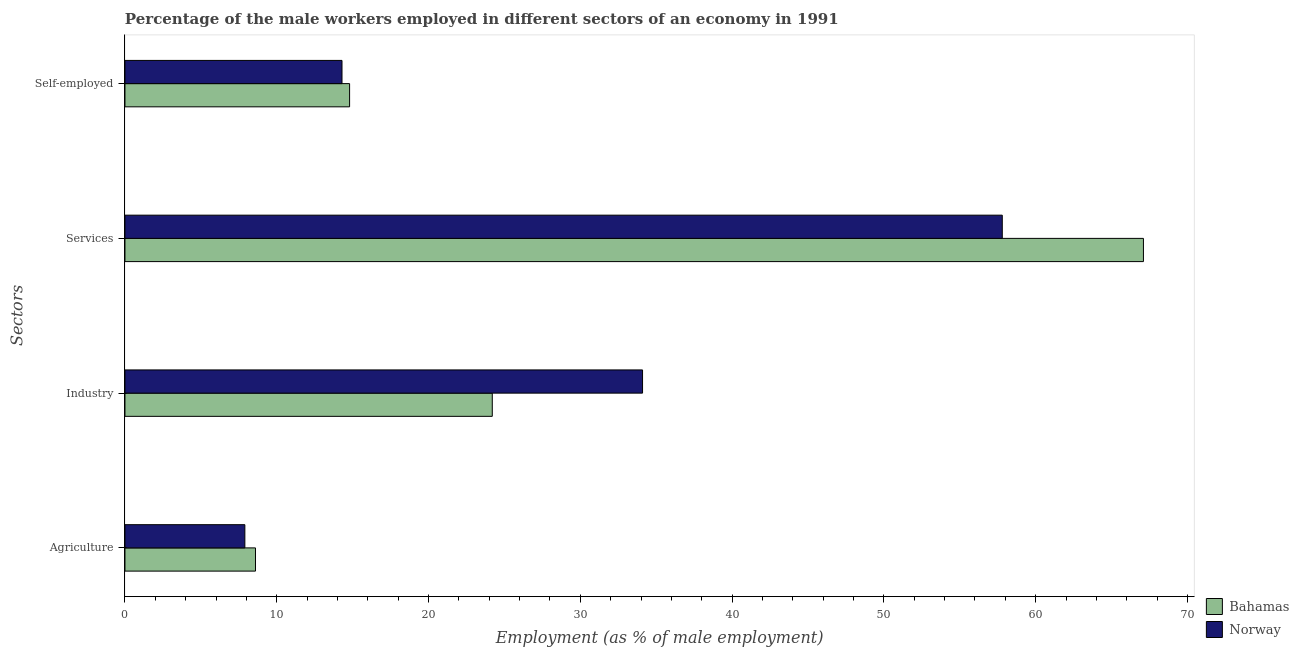How many different coloured bars are there?
Provide a succinct answer. 2. Are the number of bars on each tick of the Y-axis equal?
Provide a succinct answer. Yes. How many bars are there on the 3rd tick from the top?
Provide a short and direct response. 2. How many bars are there on the 4th tick from the bottom?
Provide a succinct answer. 2. What is the label of the 2nd group of bars from the top?
Your response must be concise. Services. What is the percentage of male workers in industry in Bahamas?
Your answer should be very brief. 24.2. Across all countries, what is the maximum percentage of male workers in services?
Offer a very short reply. 67.1. Across all countries, what is the minimum percentage of self employed male workers?
Provide a short and direct response. 14.3. In which country was the percentage of self employed male workers maximum?
Your response must be concise. Bahamas. In which country was the percentage of male workers in industry minimum?
Your answer should be very brief. Bahamas. What is the total percentage of male workers in agriculture in the graph?
Give a very brief answer. 16.5. What is the difference between the percentage of male workers in agriculture in Bahamas and that in Norway?
Ensure brevity in your answer.  0.7. What is the difference between the percentage of self employed male workers in Bahamas and the percentage of male workers in services in Norway?
Offer a terse response. -43. What is the average percentage of male workers in services per country?
Give a very brief answer. 62.45. What is the difference between the percentage of male workers in industry and percentage of self employed male workers in Bahamas?
Your answer should be very brief. 9.4. What is the ratio of the percentage of self employed male workers in Bahamas to that in Norway?
Your response must be concise. 1.03. Is the percentage of male workers in services in Bahamas less than that in Norway?
Offer a terse response. No. Is the difference between the percentage of male workers in services in Bahamas and Norway greater than the difference between the percentage of male workers in industry in Bahamas and Norway?
Provide a succinct answer. Yes. What is the difference between the highest and the second highest percentage of male workers in industry?
Offer a terse response. 9.9. What is the difference between the highest and the lowest percentage of male workers in agriculture?
Give a very brief answer. 0.7. Is the sum of the percentage of male workers in agriculture in Norway and Bahamas greater than the maximum percentage of self employed male workers across all countries?
Give a very brief answer. Yes. Is it the case that in every country, the sum of the percentage of male workers in industry and percentage of male workers in services is greater than the sum of percentage of self employed male workers and percentage of male workers in agriculture?
Your answer should be compact. Yes. What does the 2nd bar from the top in Industry represents?
Provide a short and direct response. Bahamas. What does the 1st bar from the bottom in Services represents?
Ensure brevity in your answer.  Bahamas. How many bars are there?
Make the answer very short. 8. Are the values on the major ticks of X-axis written in scientific E-notation?
Your answer should be compact. No. Does the graph contain any zero values?
Your response must be concise. No. Where does the legend appear in the graph?
Give a very brief answer. Bottom right. How are the legend labels stacked?
Give a very brief answer. Vertical. What is the title of the graph?
Your answer should be very brief. Percentage of the male workers employed in different sectors of an economy in 1991. What is the label or title of the X-axis?
Offer a terse response. Employment (as % of male employment). What is the label or title of the Y-axis?
Your answer should be compact. Sectors. What is the Employment (as % of male employment) in Bahamas in Agriculture?
Your answer should be compact. 8.6. What is the Employment (as % of male employment) of Norway in Agriculture?
Provide a short and direct response. 7.9. What is the Employment (as % of male employment) of Bahamas in Industry?
Ensure brevity in your answer.  24.2. What is the Employment (as % of male employment) of Norway in Industry?
Provide a short and direct response. 34.1. What is the Employment (as % of male employment) of Bahamas in Services?
Make the answer very short. 67.1. What is the Employment (as % of male employment) of Norway in Services?
Your answer should be compact. 57.8. What is the Employment (as % of male employment) of Bahamas in Self-employed?
Provide a succinct answer. 14.8. What is the Employment (as % of male employment) in Norway in Self-employed?
Provide a succinct answer. 14.3. Across all Sectors, what is the maximum Employment (as % of male employment) in Bahamas?
Make the answer very short. 67.1. Across all Sectors, what is the maximum Employment (as % of male employment) in Norway?
Your response must be concise. 57.8. Across all Sectors, what is the minimum Employment (as % of male employment) of Bahamas?
Your answer should be very brief. 8.6. Across all Sectors, what is the minimum Employment (as % of male employment) of Norway?
Ensure brevity in your answer.  7.9. What is the total Employment (as % of male employment) in Bahamas in the graph?
Make the answer very short. 114.7. What is the total Employment (as % of male employment) of Norway in the graph?
Offer a very short reply. 114.1. What is the difference between the Employment (as % of male employment) of Bahamas in Agriculture and that in Industry?
Your answer should be compact. -15.6. What is the difference between the Employment (as % of male employment) in Norway in Agriculture and that in Industry?
Give a very brief answer. -26.2. What is the difference between the Employment (as % of male employment) in Bahamas in Agriculture and that in Services?
Make the answer very short. -58.5. What is the difference between the Employment (as % of male employment) of Norway in Agriculture and that in Services?
Your answer should be very brief. -49.9. What is the difference between the Employment (as % of male employment) in Bahamas in Agriculture and that in Self-employed?
Your response must be concise. -6.2. What is the difference between the Employment (as % of male employment) of Bahamas in Industry and that in Services?
Provide a succinct answer. -42.9. What is the difference between the Employment (as % of male employment) of Norway in Industry and that in Services?
Provide a succinct answer. -23.7. What is the difference between the Employment (as % of male employment) of Norway in Industry and that in Self-employed?
Keep it short and to the point. 19.8. What is the difference between the Employment (as % of male employment) in Bahamas in Services and that in Self-employed?
Your answer should be compact. 52.3. What is the difference between the Employment (as % of male employment) of Norway in Services and that in Self-employed?
Your answer should be very brief. 43.5. What is the difference between the Employment (as % of male employment) of Bahamas in Agriculture and the Employment (as % of male employment) of Norway in Industry?
Give a very brief answer. -25.5. What is the difference between the Employment (as % of male employment) in Bahamas in Agriculture and the Employment (as % of male employment) in Norway in Services?
Make the answer very short. -49.2. What is the difference between the Employment (as % of male employment) of Bahamas in Agriculture and the Employment (as % of male employment) of Norway in Self-employed?
Your response must be concise. -5.7. What is the difference between the Employment (as % of male employment) in Bahamas in Industry and the Employment (as % of male employment) in Norway in Services?
Provide a short and direct response. -33.6. What is the difference between the Employment (as % of male employment) in Bahamas in Services and the Employment (as % of male employment) in Norway in Self-employed?
Ensure brevity in your answer.  52.8. What is the average Employment (as % of male employment) of Bahamas per Sectors?
Ensure brevity in your answer.  28.68. What is the average Employment (as % of male employment) of Norway per Sectors?
Offer a terse response. 28.52. What is the difference between the Employment (as % of male employment) of Bahamas and Employment (as % of male employment) of Norway in Agriculture?
Make the answer very short. 0.7. What is the difference between the Employment (as % of male employment) in Bahamas and Employment (as % of male employment) in Norway in Self-employed?
Give a very brief answer. 0.5. What is the ratio of the Employment (as % of male employment) in Bahamas in Agriculture to that in Industry?
Your response must be concise. 0.36. What is the ratio of the Employment (as % of male employment) in Norway in Agriculture to that in Industry?
Provide a short and direct response. 0.23. What is the ratio of the Employment (as % of male employment) of Bahamas in Agriculture to that in Services?
Provide a short and direct response. 0.13. What is the ratio of the Employment (as % of male employment) of Norway in Agriculture to that in Services?
Your response must be concise. 0.14. What is the ratio of the Employment (as % of male employment) of Bahamas in Agriculture to that in Self-employed?
Ensure brevity in your answer.  0.58. What is the ratio of the Employment (as % of male employment) in Norway in Agriculture to that in Self-employed?
Offer a terse response. 0.55. What is the ratio of the Employment (as % of male employment) of Bahamas in Industry to that in Services?
Keep it short and to the point. 0.36. What is the ratio of the Employment (as % of male employment) of Norway in Industry to that in Services?
Provide a short and direct response. 0.59. What is the ratio of the Employment (as % of male employment) in Bahamas in Industry to that in Self-employed?
Provide a succinct answer. 1.64. What is the ratio of the Employment (as % of male employment) of Norway in Industry to that in Self-employed?
Your answer should be very brief. 2.38. What is the ratio of the Employment (as % of male employment) in Bahamas in Services to that in Self-employed?
Give a very brief answer. 4.53. What is the ratio of the Employment (as % of male employment) in Norway in Services to that in Self-employed?
Your answer should be very brief. 4.04. What is the difference between the highest and the second highest Employment (as % of male employment) of Bahamas?
Your answer should be compact. 42.9. What is the difference between the highest and the second highest Employment (as % of male employment) in Norway?
Provide a short and direct response. 23.7. What is the difference between the highest and the lowest Employment (as % of male employment) in Bahamas?
Ensure brevity in your answer.  58.5. What is the difference between the highest and the lowest Employment (as % of male employment) in Norway?
Your answer should be compact. 49.9. 